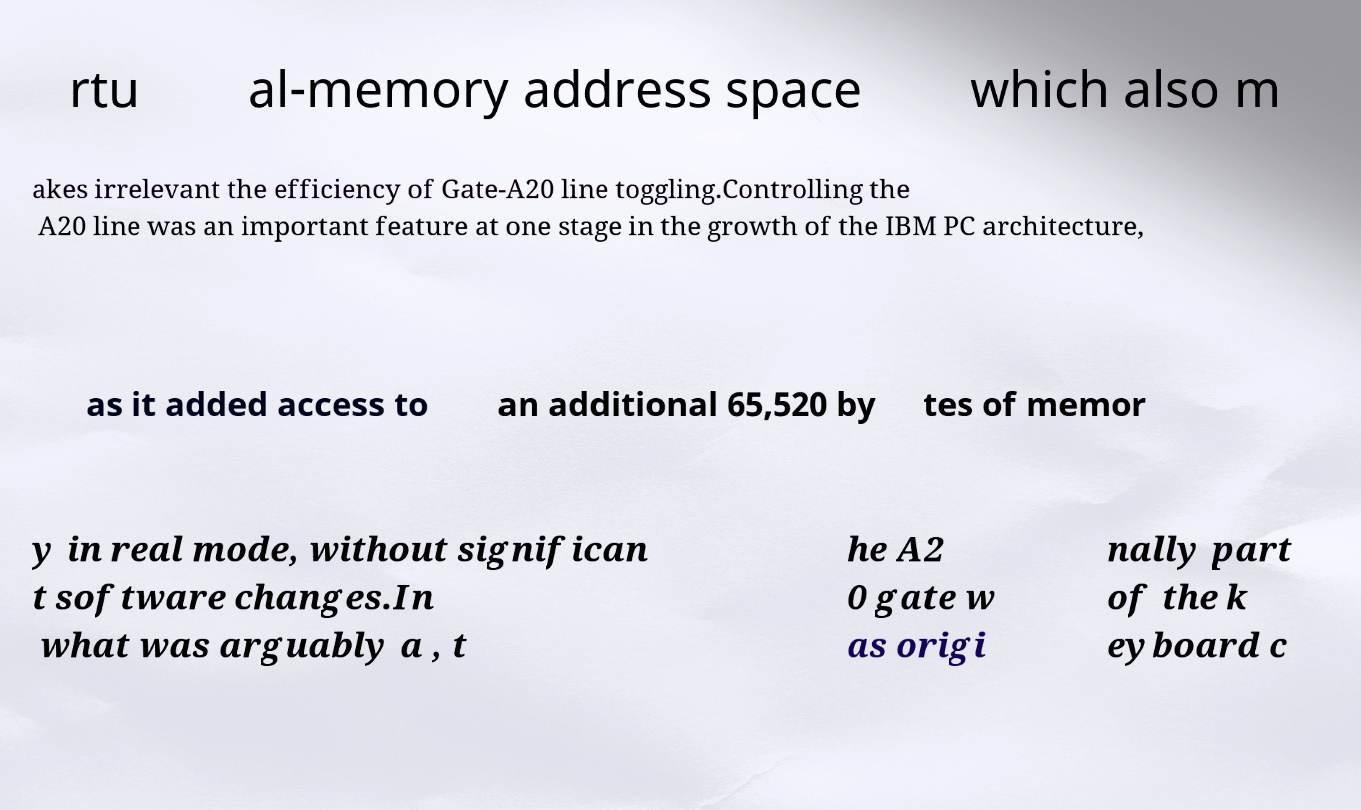Can you read and provide the text displayed in the image?This photo seems to have some interesting text. Can you extract and type it out for me? rtu al-memory address space which also m akes irrelevant the efficiency of Gate-A20 line toggling.Controlling the A20 line was an important feature at one stage in the growth of the IBM PC architecture, as it added access to an additional 65,520 by tes of memor y in real mode, without significan t software changes.In what was arguably a , t he A2 0 gate w as origi nally part of the k eyboard c 